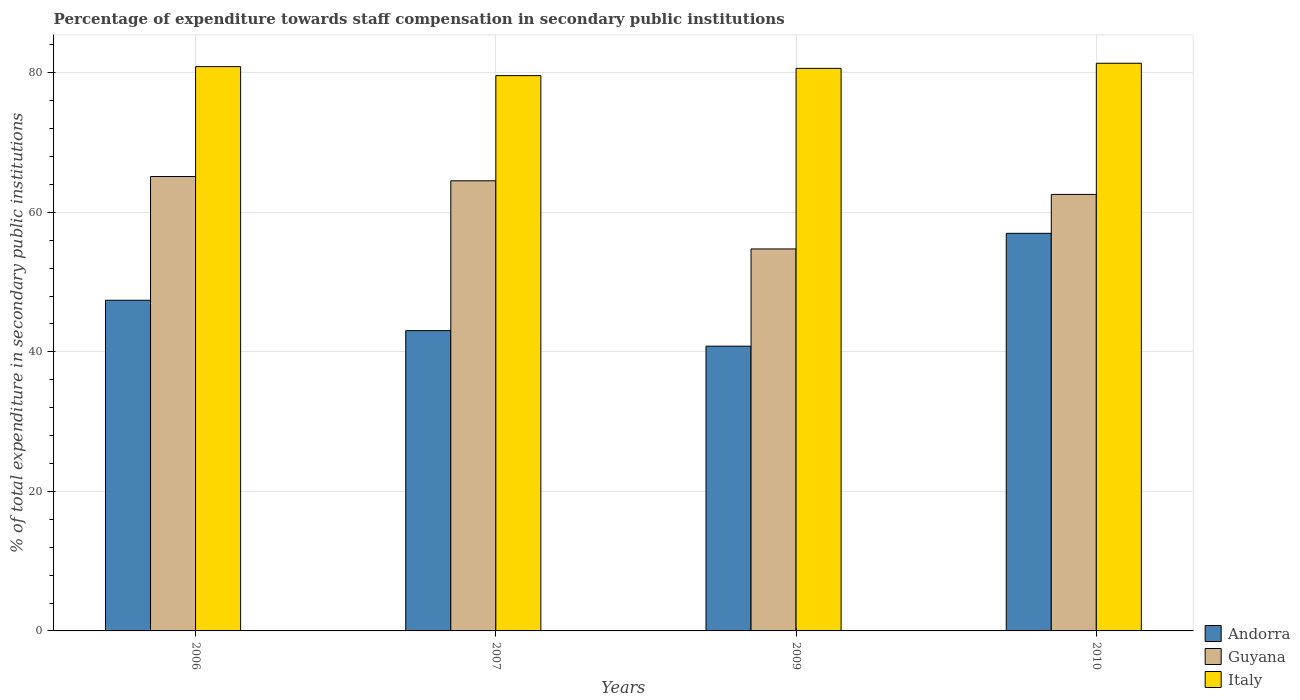How many groups of bars are there?
Offer a terse response. 4. How many bars are there on the 2nd tick from the left?
Your answer should be very brief. 3. In how many cases, is the number of bars for a given year not equal to the number of legend labels?
Offer a terse response. 0. What is the percentage of expenditure towards staff compensation in Italy in 2006?
Keep it short and to the point. 80.89. Across all years, what is the maximum percentage of expenditure towards staff compensation in Andorra?
Ensure brevity in your answer.  56.99. Across all years, what is the minimum percentage of expenditure towards staff compensation in Italy?
Your response must be concise. 79.6. What is the total percentage of expenditure towards staff compensation in Guyana in the graph?
Keep it short and to the point. 246.98. What is the difference between the percentage of expenditure towards staff compensation in Andorra in 2007 and that in 2009?
Make the answer very short. 2.22. What is the difference between the percentage of expenditure towards staff compensation in Guyana in 2010 and the percentage of expenditure towards staff compensation in Italy in 2006?
Your response must be concise. -18.31. What is the average percentage of expenditure towards staff compensation in Italy per year?
Your response must be concise. 80.62. In the year 2009, what is the difference between the percentage of expenditure towards staff compensation in Italy and percentage of expenditure towards staff compensation in Andorra?
Offer a terse response. 39.82. What is the ratio of the percentage of expenditure towards staff compensation in Italy in 2007 to that in 2009?
Your response must be concise. 0.99. Is the percentage of expenditure towards staff compensation in Andorra in 2006 less than that in 2009?
Your answer should be compact. No. Is the difference between the percentage of expenditure towards staff compensation in Italy in 2009 and 2010 greater than the difference between the percentage of expenditure towards staff compensation in Andorra in 2009 and 2010?
Your answer should be compact. Yes. What is the difference between the highest and the second highest percentage of expenditure towards staff compensation in Andorra?
Your answer should be very brief. 9.59. What is the difference between the highest and the lowest percentage of expenditure towards staff compensation in Italy?
Ensure brevity in your answer.  1.77. In how many years, is the percentage of expenditure towards staff compensation in Andorra greater than the average percentage of expenditure towards staff compensation in Andorra taken over all years?
Give a very brief answer. 2. Is the sum of the percentage of expenditure towards staff compensation in Andorra in 2006 and 2007 greater than the maximum percentage of expenditure towards staff compensation in Guyana across all years?
Offer a very short reply. Yes. What does the 1st bar from the left in 2009 represents?
Your answer should be compact. Andorra. What does the 1st bar from the right in 2010 represents?
Your response must be concise. Italy. Is it the case that in every year, the sum of the percentage of expenditure towards staff compensation in Guyana and percentage of expenditure towards staff compensation in Andorra is greater than the percentage of expenditure towards staff compensation in Italy?
Offer a very short reply. Yes. How many bars are there?
Make the answer very short. 12. What is the difference between two consecutive major ticks on the Y-axis?
Give a very brief answer. 20. Are the values on the major ticks of Y-axis written in scientific E-notation?
Provide a short and direct response. No. What is the title of the graph?
Offer a terse response. Percentage of expenditure towards staff compensation in secondary public institutions. Does "Ireland" appear as one of the legend labels in the graph?
Make the answer very short. No. What is the label or title of the X-axis?
Provide a succinct answer. Years. What is the label or title of the Y-axis?
Make the answer very short. % of total expenditure in secondary public institutions. What is the % of total expenditure in secondary public institutions in Andorra in 2006?
Provide a succinct answer. 47.4. What is the % of total expenditure in secondary public institutions in Guyana in 2006?
Your response must be concise. 65.13. What is the % of total expenditure in secondary public institutions of Italy in 2006?
Give a very brief answer. 80.89. What is the % of total expenditure in secondary public institutions of Andorra in 2007?
Ensure brevity in your answer.  43.04. What is the % of total expenditure in secondary public institutions in Guyana in 2007?
Make the answer very short. 64.52. What is the % of total expenditure in secondary public institutions in Italy in 2007?
Your answer should be very brief. 79.6. What is the % of total expenditure in secondary public institutions in Andorra in 2009?
Keep it short and to the point. 40.82. What is the % of total expenditure in secondary public institutions in Guyana in 2009?
Offer a terse response. 54.75. What is the % of total expenditure in secondary public institutions in Italy in 2009?
Your answer should be compact. 80.64. What is the % of total expenditure in secondary public institutions of Andorra in 2010?
Your response must be concise. 56.99. What is the % of total expenditure in secondary public institutions in Guyana in 2010?
Ensure brevity in your answer.  62.57. What is the % of total expenditure in secondary public institutions of Italy in 2010?
Provide a short and direct response. 81.37. Across all years, what is the maximum % of total expenditure in secondary public institutions in Andorra?
Your response must be concise. 56.99. Across all years, what is the maximum % of total expenditure in secondary public institutions in Guyana?
Provide a short and direct response. 65.13. Across all years, what is the maximum % of total expenditure in secondary public institutions in Italy?
Your answer should be compact. 81.37. Across all years, what is the minimum % of total expenditure in secondary public institutions in Andorra?
Offer a terse response. 40.82. Across all years, what is the minimum % of total expenditure in secondary public institutions in Guyana?
Ensure brevity in your answer.  54.75. Across all years, what is the minimum % of total expenditure in secondary public institutions of Italy?
Keep it short and to the point. 79.6. What is the total % of total expenditure in secondary public institutions in Andorra in the graph?
Provide a short and direct response. 188.25. What is the total % of total expenditure in secondary public institutions of Guyana in the graph?
Keep it short and to the point. 246.98. What is the total % of total expenditure in secondary public institutions in Italy in the graph?
Offer a terse response. 322.49. What is the difference between the % of total expenditure in secondary public institutions of Andorra in 2006 and that in 2007?
Provide a succinct answer. 4.36. What is the difference between the % of total expenditure in secondary public institutions of Guyana in 2006 and that in 2007?
Your answer should be very brief. 0.61. What is the difference between the % of total expenditure in secondary public institutions of Italy in 2006 and that in 2007?
Your answer should be very brief. 1.29. What is the difference between the % of total expenditure in secondary public institutions in Andorra in 2006 and that in 2009?
Offer a very short reply. 6.58. What is the difference between the % of total expenditure in secondary public institutions in Guyana in 2006 and that in 2009?
Keep it short and to the point. 10.38. What is the difference between the % of total expenditure in secondary public institutions of Italy in 2006 and that in 2009?
Keep it short and to the point. 0.25. What is the difference between the % of total expenditure in secondary public institutions in Andorra in 2006 and that in 2010?
Provide a succinct answer. -9.59. What is the difference between the % of total expenditure in secondary public institutions in Guyana in 2006 and that in 2010?
Provide a succinct answer. 2.56. What is the difference between the % of total expenditure in secondary public institutions in Italy in 2006 and that in 2010?
Make the answer very short. -0.48. What is the difference between the % of total expenditure in secondary public institutions of Andorra in 2007 and that in 2009?
Your answer should be compact. 2.22. What is the difference between the % of total expenditure in secondary public institutions in Guyana in 2007 and that in 2009?
Your response must be concise. 9.77. What is the difference between the % of total expenditure in secondary public institutions of Italy in 2007 and that in 2009?
Your answer should be very brief. -1.04. What is the difference between the % of total expenditure in secondary public institutions in Andorra in 2007 and that in 2010?
Your answer should be compact. -13.95. What is the difference between the % of total expenditure in secondary public institutions in Guyana in 2007 and that in 2010?
Your answer should be very brief. 1.95. What is the difference between the % of total expenditure in secondary public institutions of Italy in 2007 and that in 2010?
Make the answer very short. -1.77. What is the difference between the % of total expenditure in secondary public institutions of Andorra in 2009 and that in 2010?
Make the answer very short. -16.18. What is the difference between the % of total expenditure in secondary public institutions of Guyana in 2009 and that in 2010?
Provide a succinct answer. -7.82. What is the difference between the % of total expenditure in secondary public institutions in Italy in 2009 and that in 2010?
Your answer should be very brief. -0.73. What is the difference between the % of total expenditure in secondary public institutions of Andorra in 2006 and the % of total expenditure in secondary public institutions of Guyana in 2007?
Your answer should be compact. -17.12. What is the difference between the % of total expenditure in secondary public institutions in Andorra in 2006 and the % of total expenditure in secondary public institutions in Italy in 2007?
Offer a terse response. -32.2. What is the difference between the % of total expenditure in secondary public institutions of Guyana in 2006 and the % of total expenditure in secondary public institutions of Italy in 2007?
Offer a terse response. -14.47. What is the difference between the % of total expenditure in secondary public institutions of Andorra in 2006 and the % of total expenditure in secondary public institutions of Guyana in 2009?
Ensure brevity in your answer.  -7.35. What is the difference between the % of total expenditure in secondary public institutions of Andorra in 2006 and the % of total expenditure in secondary public institutions of Italy in 2009?
Provide a short and direct response. -33.24. What is the difference between the % of total expenditure in secondary public institutions of Guyana in 2006 and the % of total expenditure in secondary public institutions of Italy in 2009?
Ensure brevity in your answer.  -15.5. What is the difference between the % of total expenditure in secondary public institutions in Andorra in 2006 and the % of total expenditure in secondary public institutions in Guyana in 2010?
Give a very brief answer. -15.17. What is the difference between the % of total expenditure in secondary public institutions in Andorra in 2006 and the % of total expenditure in secondary public institutions in Italy in 2010?
Provide a succinct answer. -33.97. What is the difference between the % of total expenditure in secondary public institutions in Guyana in 2006 and the % of total expenditure in secondary public institutions in Italy in 2010?
Your answer should be very brief. -16.24. What is the difference between the % of total expenditure in secondary public institutions in Andorra in 2007 and the % of total expenditure in secondary public institutions in Guyana in 2009?
Your answer should be very brief. -11.71. What is the difference between the % of total expenditure in secondary public institutions of Andorra in 2007 and the % of total expenditure in secondary public institutions of Italy in 2009?
Ensure brevity in your answer.  -37.59. What is the difference between the % of total expenditure in secondary public institutions in Guyana in 2007 and the % of total expenditure in secondary public institutions in Italy in 2009?
Provide a short and direct response. -16.12. What is the difference between the % of total expenditure in secondary public institutions in Andorra in 2007 and the % of total expenditure in secondary public institutions in Guyana in 2010?
Your answer should be very brief. -19.53. What is the difference between the % of total expenditure in secondary public institutions of Andorra in 2007 and the % of total expenditure in secondary public institutions of Italy in 2010?
Your answer should be compact. -38.33. What is the difference between the % of total expenditure in secondary public institutions of Guyana in 2007 and the % of total expenditure in secondary public institutions of Italy in 2010?
Offer a terse response. -16.85. What is the difference between the % of total expenditure in secondary public institutions in Andorra in 2009 and the % of total expenditure in secondary public institutions in Guyana in 2010?
Make the answer very short. -21.75. What is the difference between the % of total expenditure in secondary public institutions in Andorra in 2009 and the % of total expenditure in secondary public institutions in Italy in 2010?
Your answer should be compact. -40.55. What is the difference between the % of total expenditure in secondary public institutions in Guyana in 2009 and the % of total expenditure in secondary public institutions in Italy in 2010?
Make the answer very short. -26.62. What is the average % of total expenditure in secondary public institutions of Andorra per year?
Keep it short and to the point. 47.06. What is the average % of total expenditure in secondary public institutions in Guyana per year?
Give a very brief answer. 61.74. What is the average % of total expenditure in secondary public institutions of Italy per year?
Ensure brevity in your answer.  80.62. In the year 2006, what is the difference between the % of total expenditure in secondary public institutions of Andorra and % of total expenditure in secondary public institutions of Guyana?
Your answer should be compact. -17.73. In the year 2006, what is the difference between the % of total expenditure in secondary public institutions in Andorra and % of total expenditure in secondary public institutions in Italy?
Make the answer very short. -33.49. In the year 2006, what is the difference between the % of total expenditure in secondary public institutions of Guyana and % of total expenditure in secondary public institutions of Italy?
Ensure brevity in your answer.  -15.75. In the year 2007, what is the difference between the % of total expenditure in secondary public institutions in Andorra and % of total expenditure in secondary public institutions in Guyana?
Offer a very short reply. -21.48. In the year 2007, what is the difference between the % of total expenditure in secondary public institutions of Andorra and % of total expenditure in secondary public institutions of Italy?
Offer a terse response. -36.56. In the year 2007, what is the difference between the % of total expenditure in secondary public institutions of Guyana and % of total expenditure in secondary public institutions of Italy?
Your answer should be very brief. -15.08. In the year 2009, what is the difference between the % of total expenditure in secondary public institutions of Andorra and % of total expenditure in secondary public institutions of Guyana?
Your response must be concise. -13.93. In the year 2009, what is the difference between the % of total expenditure in secondary public institutions in Andorra and % of total expenditure in secondary public institutions in Italy?
Offer a very short reply. -39.82. In the year 2009, what is the difference between the % of total expenditure in secondary public institutions in Guyana and % of total expenditure in secondary public institutions in Italy?
Keep it short and to the point. -25.88. In the year 2010, what is the difference between the % of total expenditure in secondary public institutions of Andorra and % of total expenditure in secondary public institutions of Guyana?
Make the answer very short. -5.58. In the year 2010, what is the difference between the % of total expenditure in secondary public institutions in Andorra and % of total expenditure in secondary public institutions in Italy?
Your answer should be compact. -24.38. In the year 2010, what is the difference between the % of total expenditure in secondary public institutions in Guyana and % of total expenditure in secondary public institutions in Italy?
Your answer should be very brief. -18.8. What is the ratio of the % of total expenditure in secondary public institutions in Andorra in 2006 to that in 2007?
Your answer should be compact. 1.1. What is the ratio of the % of total expenditure in secondary public institutions in Guyana in 2006 to that in 2007?
Your answer should be compact. 1.01. What is the ratio of the % of total expenditure in secondary public institutions of Italy in 2006 to that in 2007?
Your answer should be compact. 1.02. What is the ratio of the % of total expenditure in secondary public institutions of Andorra in 2006 to that in 2009?
Provide a succinct answer. 1.16. What is the ratio of the % of total expenditure in secondary public institutions of Guyana in 2006 to that in 2009?
Provide a short and direct response. 1.19. What is the ratio of the % of total expenditure in secondary public institutions in Andorra in 2006 to that in 2010?
Provide a succinct answer. 0.83. What is the ratio of the % of total expenditure in secondary public institutions in Guyana in 2006 to that in 2010?
Make the answer very short. 1.04. What is the ratio of the % of total expenditure in secondary public institutions of Andorra in 2007 to that in 2009?
Your answer should be compact. 1.05. What is the ratio of the % of total expenditure in secondary public institutions in Guyana in 2007 to that in 2009?
Offer a terse response. 1.18. What is the ratio of the % of total expenditure in secondary public institutions in Italy in 2007 to that in 2009?
Offer a terse response. 0.99. What is the ratio of the % of total expenditure in secondary public institutions of Andorra in 2007 to that in 2010?
Give a very brief answer. 0.76. What is the ratio of the % of total expenditure in secondary public institutions of Guyana in 2007 to that in 2010?
Offer a terse response. 1.03. What is the ratio of the % of total expenditure in secondary public institutions in Italy in 2007 to that in 2010?
Ensure brevity in your answer.  0.98. What is the ratio of the % of total expenditure in secondary public institutions in Andorra in 2009 to that in 2010?
Your answer should be compact. 0.72. What is the ratio of the % of total expenditure in secondary public institutions in Guyana in 2009 to that in 2010?
Your response must be concise. 0.88. What is the difference between the highest and the second highest % of total expenditure in secondary public institutions of Andorra?
Keep it short and to the point. 9.59. What is the difference between the highest and the second highest % of total expenditure in secondary public institutions of Guyana?
Provide a short and direct response. 0.61. What is the difference between the highest and the second highest % of total expenditure in secondary public institutions of Italy?
Keep it short and to the point. 0.48. What is the difference between the highest and the lowest % of total expenditure in secondary public institutions of Andorra?
Give a very brief answer. 16.18. What is the difference between the highest and the lowest % of total expenditure in secondary public institutions in Guyana?
Offer a very short reply. 10.38. What is the difference between the highest and the lowest % of total expenditure in secondary public institutions in Italy?
Provide a succinct answer. 1.77. 